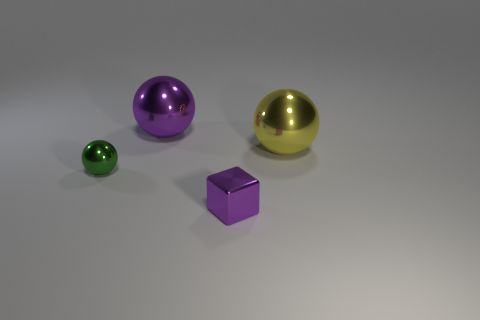Add 3 small metallic things. How many objects exist? 7 Subtract all cubes. How many objects are left? 3 Subtract all tiny red shiny blocks. Subtract all tiny shiny cubes. How many objects are left? 3 Add 4 large metallic balls. How many large metallic balls are left? 6 Add 3 big yellow rubber objects. How many big yellow rubber objects exist? 3 Subtract 0 purple cylinders. How many objects are left? 4 